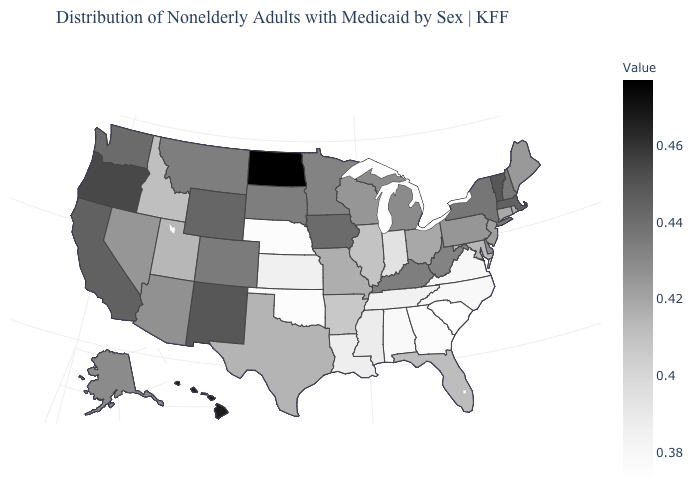Among the states that border Arkansas , does Louisiana have the highest value?
Concise answer only. No. Which states have the highest value in the USA?
Write a very short answer. North Dakota. Among the states that border Pennsylvania , does New York have the highest value?
Quick response, please. Yes. Which states have the highest value in the USA?
Answer briefly. North Dakota. Among the states that border Arkansas , which have the lowest value?
Be succinct. Oklahoma. 